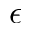<formula> <loc_0><loc_0><loc_500><loc_500>\epsilon</formula> 